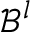<formula> <loc_0><loc_0><loc_500><loc_500>\mathcal { B } ^ { l }</formula> 